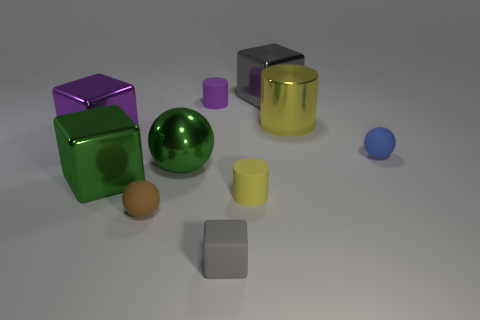How many objects are there in total in the image? There are a total of seven objects visible in the image. 